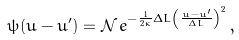Convert formula to latex. <formula><loc_0><loc_0><loc_500><loc_500>\psi ( u - u ^ { \prime } ) = \mathcal { N } \, e ^ { - \frac { 1 } { 2 \kappa } \Delta L \left ( \frac { u - u ^ { \prime } } { \Delta L } \right ) ^ { 2 } } \, ,</formula> 